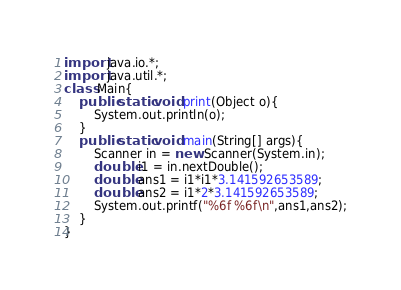<code> <loc_0><loc_0><loc_500><loc_500><_Java_>import java.io.*;
import java.util.*;
class Main{
	public static void print(Object o){
		System.out.println(o);
	}
	public static void main(String[] args){
		Scanner in = new Scanner(System.in);
		double i1 = in.nextDouble();
		double ans1 = i1*i1*3.141592653589;
		double ans2 = i1*2*3.141592653589;
		System.out.printf("%6f %6f\n",ans1,ans2);
	}
}</code> 